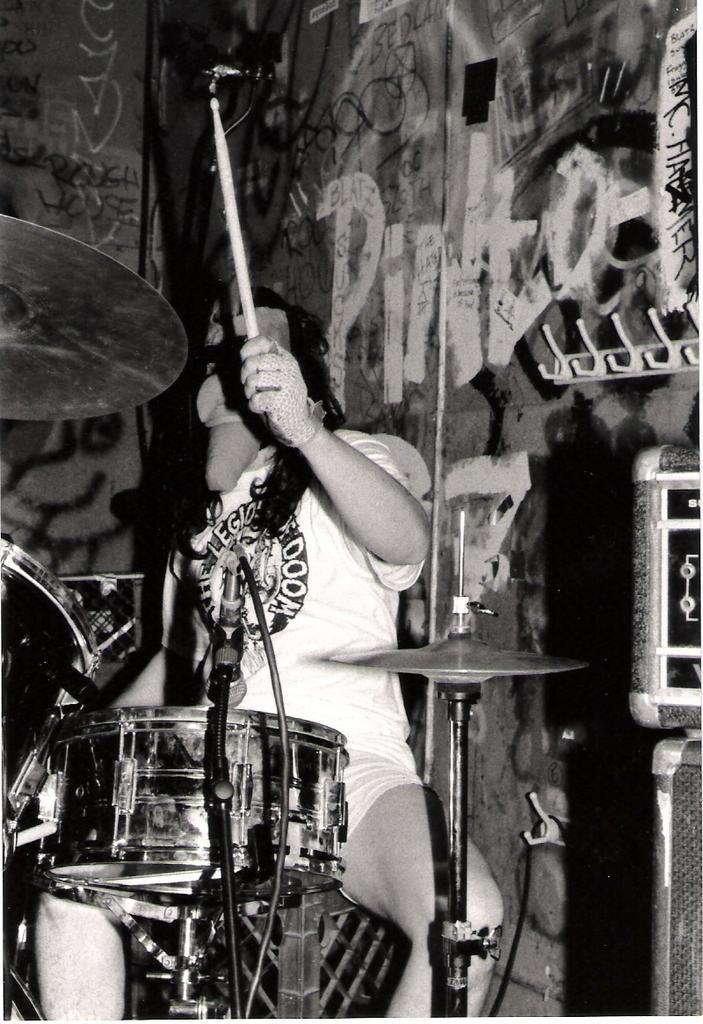Please provide a concise description of this image. This picture shows a person playing a drums with a stick in his hands. In the background there is a wall. 